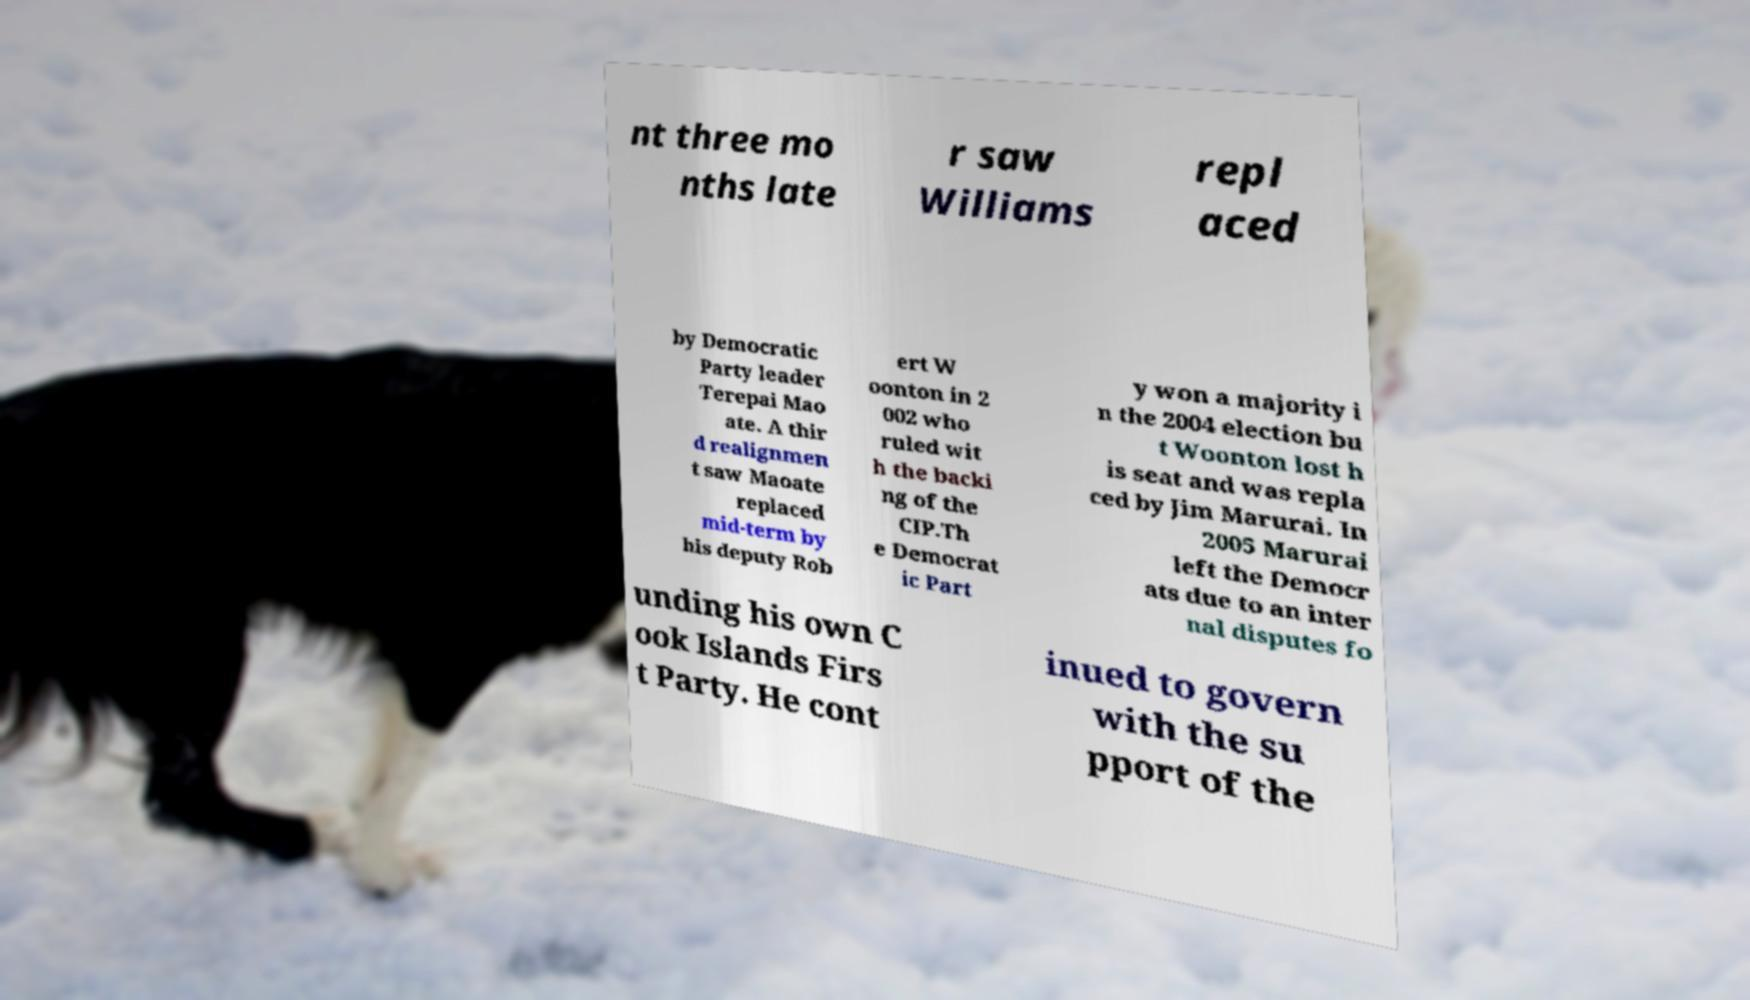There's text embedded in this image that I need extracted. Can you transcribe it verbatim? nt three mo nths late r saw Williams repl aced by Democratic Party leader Terepai Mao ate. A thir d realignmen t saw Maoate replaced mid-term by his deputy Rob ert W oonton in 2 002 who ruled wit h the backi ng of the CIP.Th e Democrat ic Part y won a majority i n the 2004 election bu t Woonton lost h is seat and was repla ced by Jim Marurai. In 2005 Marurai left the Democr ats due to an inter nal disputes fo unding his own C ook Islands Firs t Party. He cont inued to govern with the su pport of the 